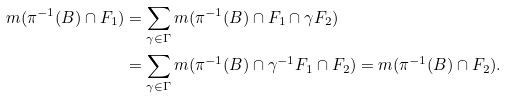Convert formula to latex. <formula><loc_0><loc_0><loc_500><loc_500>m ( \pi ^ { - 1 } ( B ) \cap F _ { 1 } ) & = \sum _ { \gamma \in \Gamma } m ( \pi ^ { - 1 } ( B ) \cap F _ { 1 } \cap \gamma F _ { 2 } ) \\ & = \sum _ { \gamma \in \Gamma } m ( \pi ^ { - 1 } ( B ) \cap \gamma ^ { - 1 } F _ { 1 } \cap F _ { 2 } ) = m ( \pi ^ { - 1 } ( B ) \cap F _ { 2 } ) .</formula> 